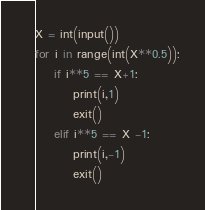Convert code to text. <code><loc_0><loc_0><loc_500><loc_500><_Python_>X = int(input())
for i in range(int(X**0.5)):
    if i**5 == X+1:
        print(i,1)
        exit()
    elif i**5 == X -1:
        print(i,-1)
        exit()
</code> 